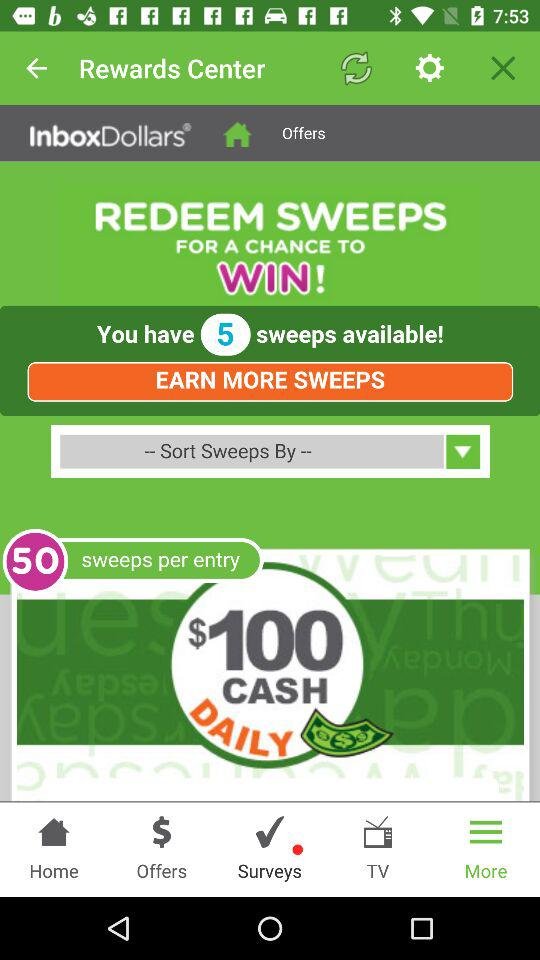How many sweeps per entry does the user have?
Answer the question using a single word or phrase. 50 